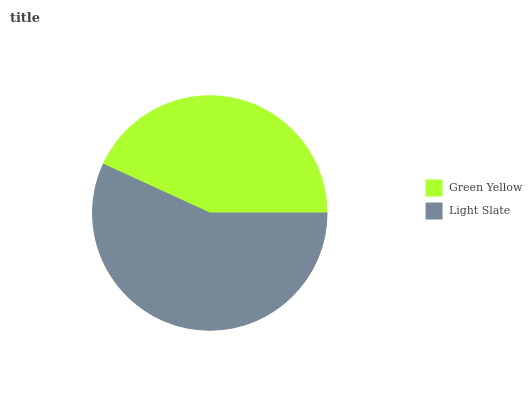Is Green Yellow the minimum?
Answer yes or no. Yes. Is Light Slate the maximum?
Answer yes or no. Yes. Is Light Slate the minimum?
Answer yes or no. No. Is Light Slate greater than Green Yellow?
Answer yes or no. Yes. Is Green Yellow less than Light Slate?
Answer yes or no. Yes. Is Green Yellow greater than Light Slate?
Answer yes or no. No. Is Light Slate less than Green Yellow?
Answer yes or no. No. Is Light Slate the high median?
Answer yes or no. Yes. Is Green Yellow the low median?
Answer yes or no. Yes. Is Green Yellow the high median?
Answer yes or no. No. Is Light Slate the low median?
Answer yes or no. No. 